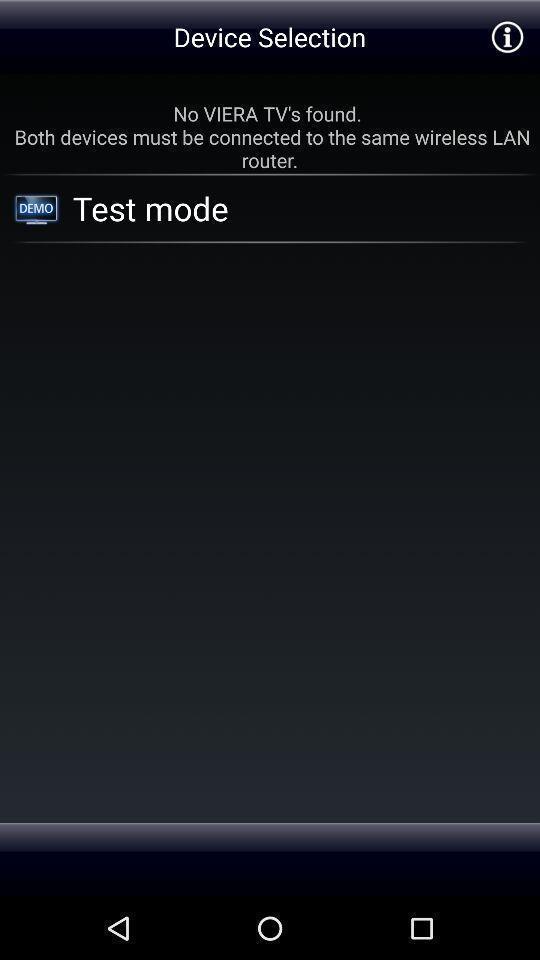What can you discern from this picture? Test mode of device selection. 